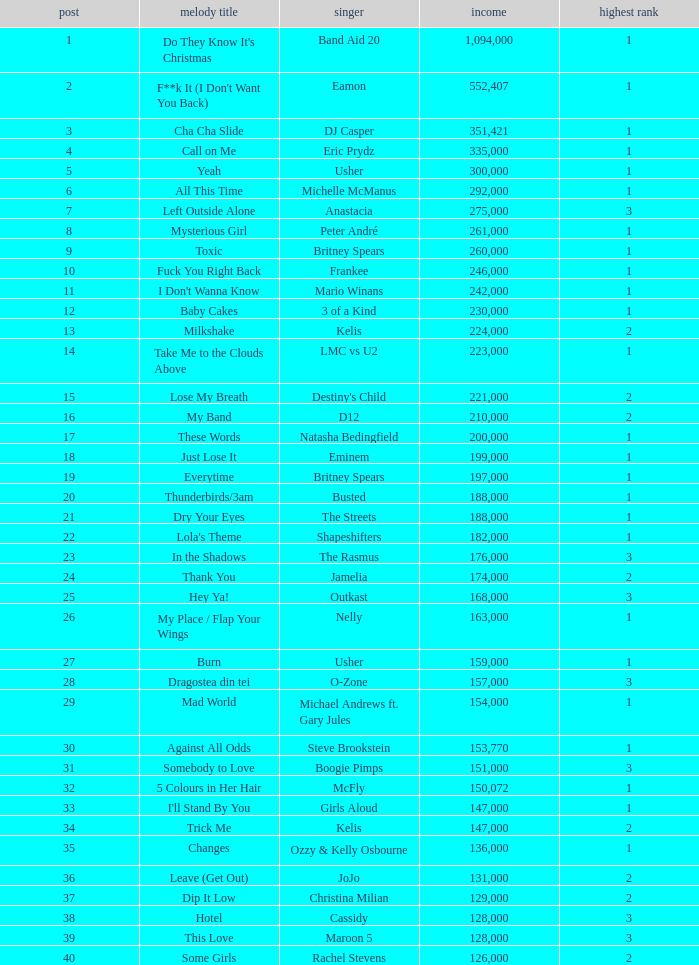What were the sales for Dj Casper when he was in a position lower than 13? 351421.0. 